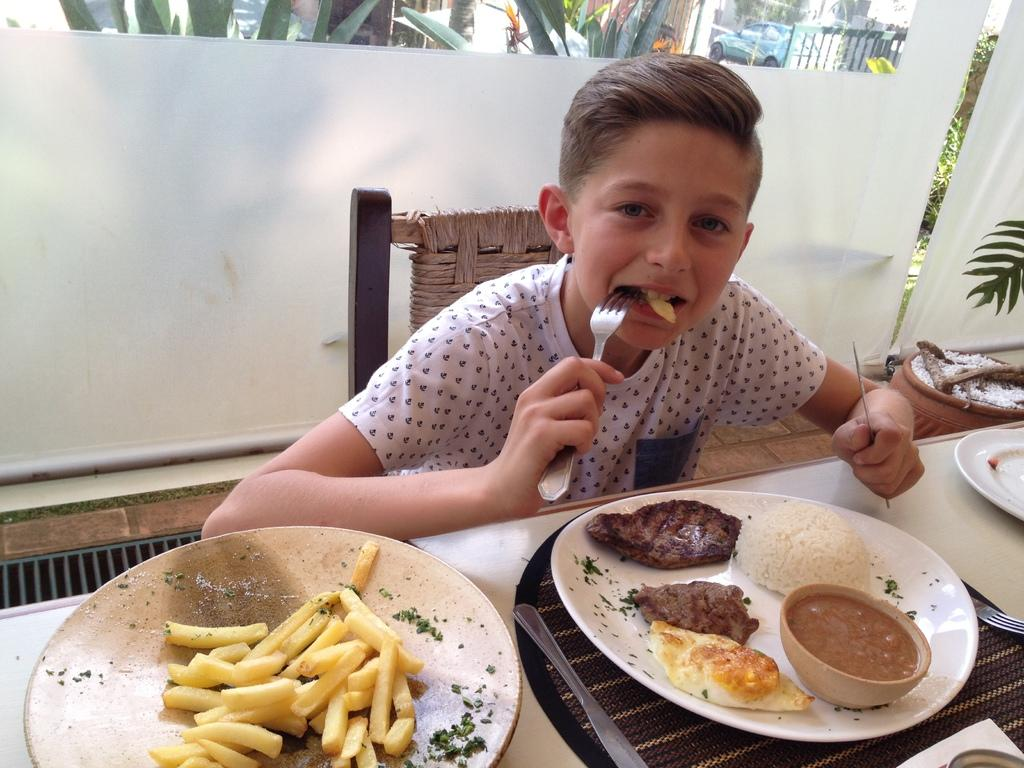What objects are on the table in the image? There are plates on the table, and the plates contain food items. What utensils are on the table? There is a fork and knife on the table. What is the boy doing in the image? The boy is eating with a fork, and he is holding a knife. What can be seen in the background of the image? There is a white curtain in the background, and plants are present at the back. What type of test is being conducted in the image? There is no indication of a test being conducted in the image. Can you see any farm animals in the image? There are no farm animals present in the image. 